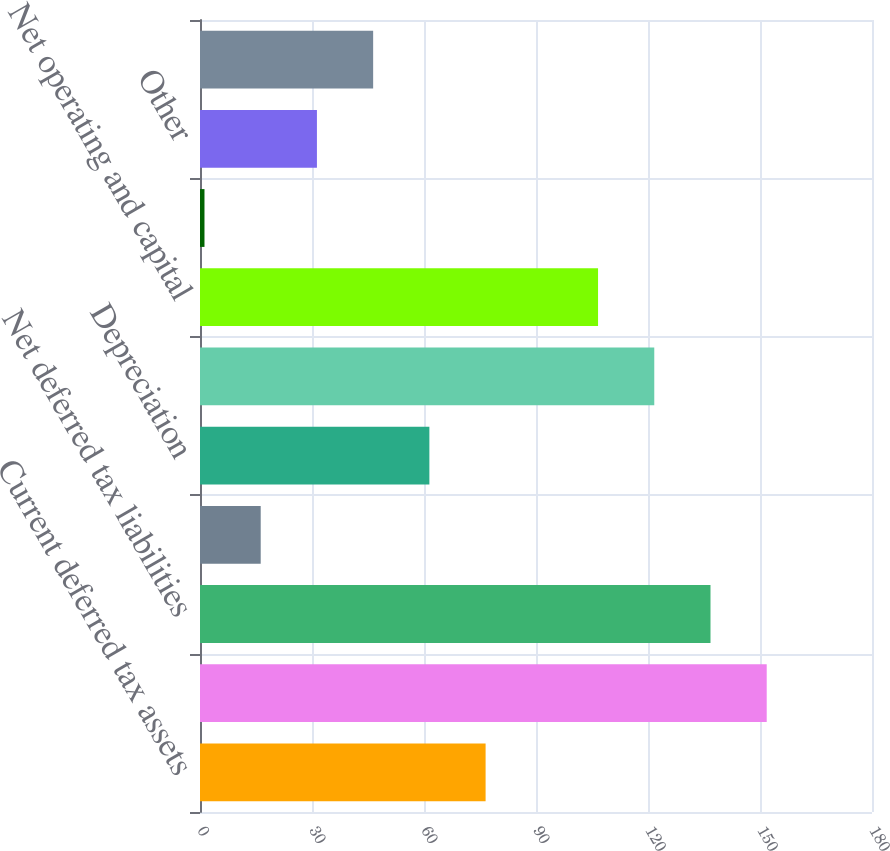<chart> <loc_0><loc_0><loc_500><loc_500><bar_chart><fcel>Current deferred tax assets<fcel>Long-term deferred tax<fcel>Net deferred tax liabilities<fcel>Accrued expenses not currently<fcel>Depreciation<fcel>Compensation and benefits not<fcel>Net operating and capital<fcel>Tax credits<fcel>Other<fcel>Less Valuation allowances<nl><fcel>76.5<fcel>151.8<fcel>136.74<fcel>16.26<fcel>61.44<fcel>121.68<fcel>106.62<fcel>1.2<fcel>31.32<fcel>46.38<nl></chart> 